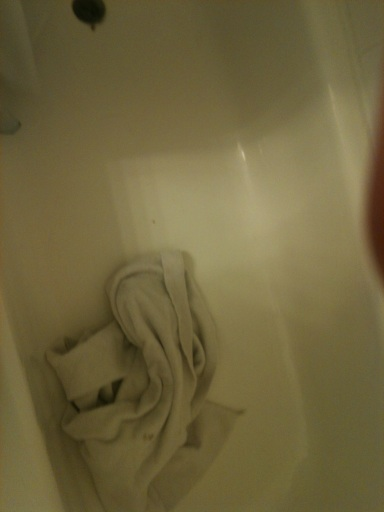Does this look clean? No, it does not appear completely clean. There's a dirty towel left inside the bathtub, which suggests it needs cleaning. Additionally, checking for any less visible stains or residue would be a good step to ensure thorough cleanliness. 